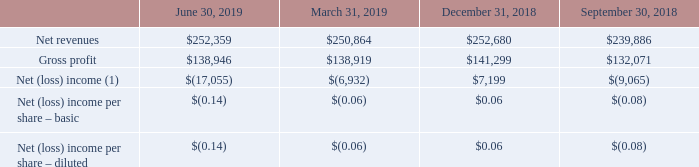Quarterly Financial Data (Unaudited)
Quarterly results for the years ended June 30, 2019 and 2018 are as follow (in thousands, except per share amounts).
What was the net revenues in September 30, 2018?
Answer scale should be: thousand. 239,886. What was the gross profit in June 30, 2019?
Answer scale should be: thousand. 138,946. What was the basic net (loss) income per share in December 31, 2018? 0.06. What was the change in the net revenues between March 31 and June 30, 2019?
Answer scale should be: thousand. 252,359-250,864
Answer: 1495. What was the change in the gross profit between September 30 and December 31, 2018?
Answer scale should be: thousand. 141,299-132,071
Answer: 9228. What was the percentage change in the net (loss) income between March 31 and June 30, 2019?
Answer scale should be: percent. (-17,055+6,932)/-6,932
Answer: 146.03. 